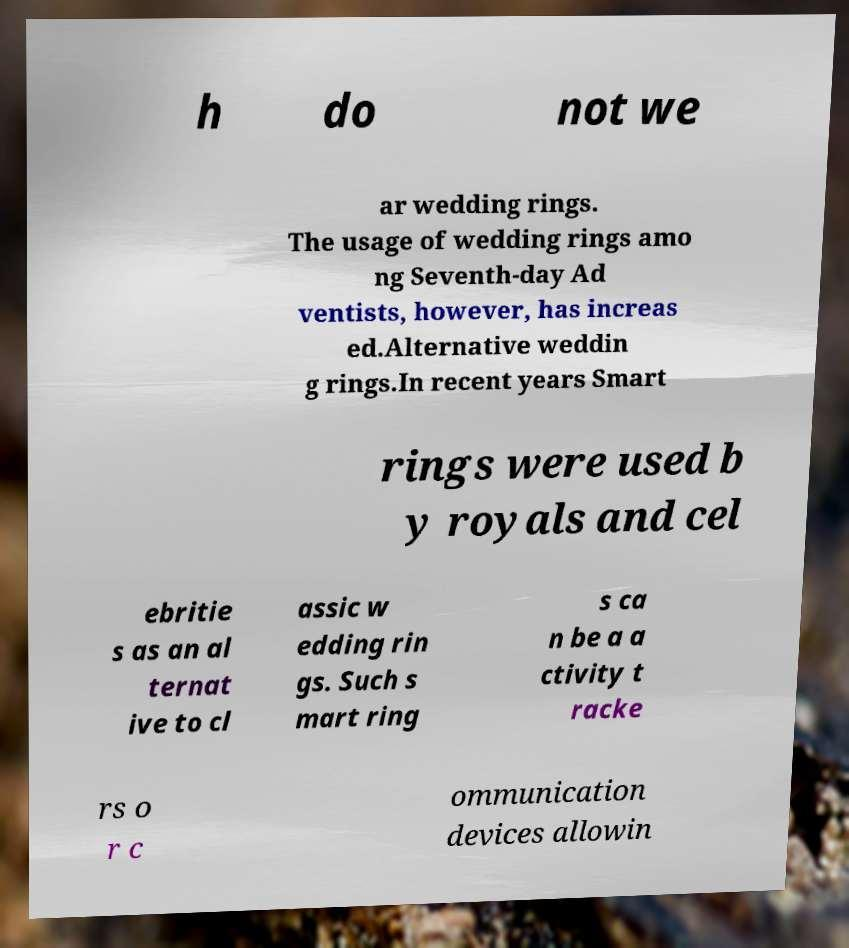Could you extract and type out the text from this image? h do not we ar wedding rings. The usage of wedding rings amo ng Seventh-day Ad ventists, however, has increas ed.Alternative weddin g rings.In recent years Smart rings were used b y royals and cel ebritie s as an al ternat ive to cl assic w edding rin gs. Such s mart ring s ca n be a a ctivity t racke rs o r c ommunication devices allowin 